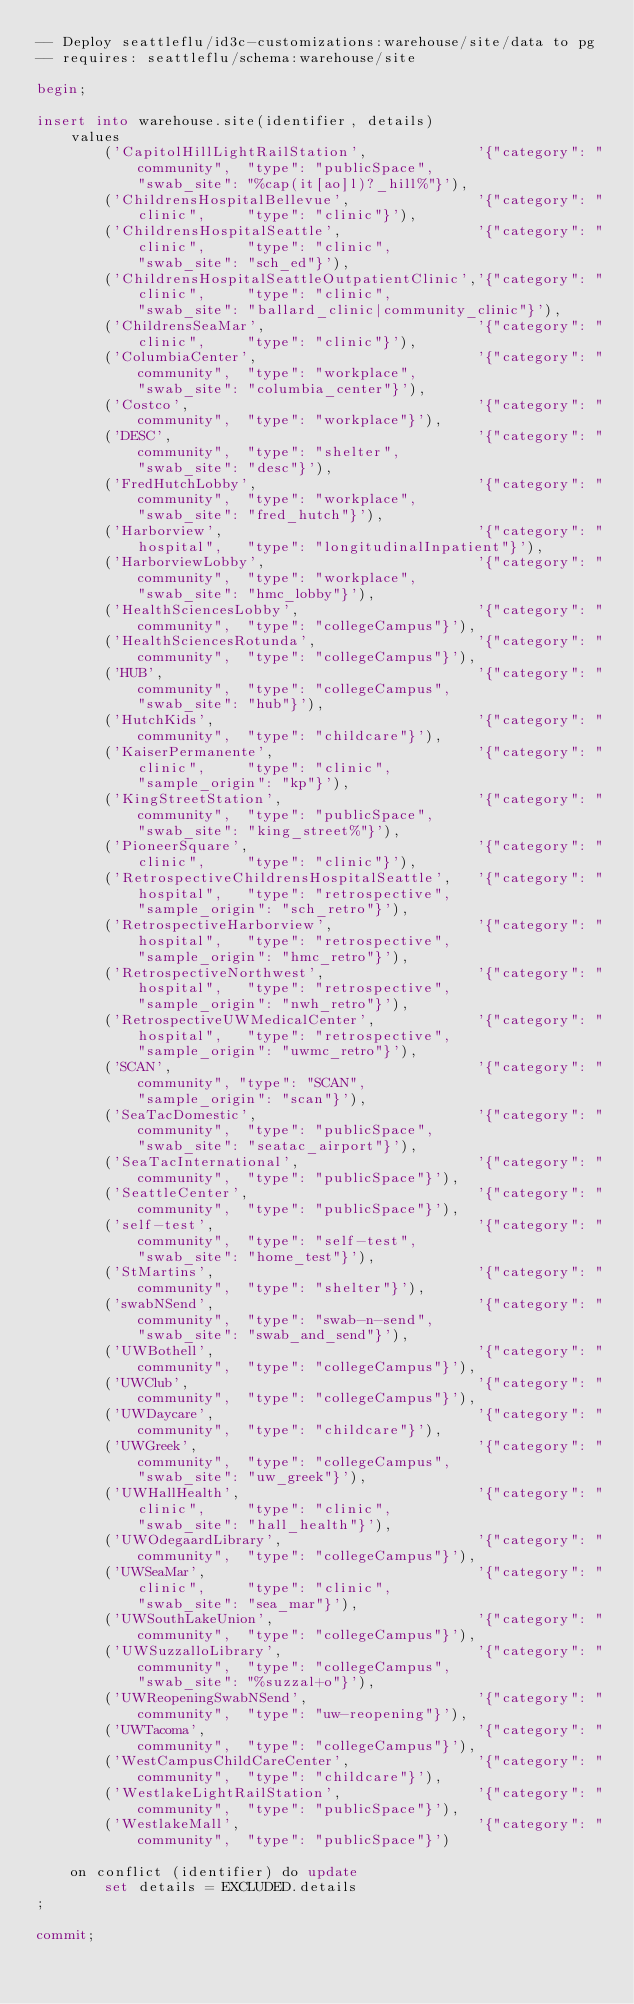Convert code to text. <code><loc_0><loc_0><loc_500><loc_500><_SQL_>-- Deploy seattleflu/id3c-customizations:warehouse/site/data to pg
-- requires: seattleflu/schema:warehouse/site

begin;

insert into warehouse.site(identifier, details)
    values
        ('CapitolHillLightRailStation',             '{"category": "community",  "type": "publicSpace",
            "swab_site": "%cap(it[ao]l)?_hill%"}'),
        ('ChildrensHospitalBellevue',               '{"category": "clinic",     "type": "clinic"}'),
        ('ChildrensHospitalSeattle',                '{"category": "clinic",     "type": "clinic",
            "swab_site": "sch_ed"}'),
        ('ChildrensHospitalSeattleOutpatientClinic','{"category": "clinic",     "type": "clinic",
            "swab_site": "ballard_clinic|community_clinic"}'),
        ('ChildrensSeaMar',                         '{"category": "clinic",     "type": "clinic"}'),
        ('ColumbiaCenter',                          '{"category": "community",  "type": "workplace",
            "swab_site": "columbia_center"}'),
        ('Costco',                                  '{"category": "community",  "type": "workplace"}'),
        ('DESC',                                    '{"category": "community",  "type": "shelter",
            "swab_site": "desc"}'),
        ('FredHutchLobby',                          '{"category": "community",  "type": "workplace",
            "swab_site": "fred_hutch"}'),
        ('Harborview',                              '{"category": "hospital",   "type": "longitudinalInpatient"}'),
        ('HarborviewLobby',                         '{"category": "community",  "type": "workplace",
            "swab_site": "hmc_lobby"}'),
        ('HealthSciencesLobby',                     '{"category": "community",  "type": "collegeCampus"}'),
        ('HealthSciencesRotunda',                   '{"category": "community",  "type": "collegeCampus"}'),
        ('HUB',                                     '{"category": "community",  "type": "collegeCampus",
            "swab_site": "hub"}'),
        ('HutchKids',                               '{"category": "community",  "type": "childcare"}'),
        ('KaiserPermanente',                        '{"category": "clinic",     "type": "clinic",
            "sample_origin": "kp"}'),
        ('KingStreetStation',                       '{"category": "community",  "type": "publicSpace",
            "swab_site": "king_street%"}'),
        ('PioneerSquare',                           '{"category": "clinic",     "type": "clinic"}'),
        ('RetrospectiveChildrensHospitalSeattle',   '{"category": "hospital",   "type": "retrospective",
            "sample_origin": "sch_retro"}'),
        ('RetrospectiveHarborview',                 '{"category": "hospital",   "type": "retrospective",
            "sample_origin": "hmc_retro"}'),
        ('RetrospectiveNorthwest',                  '{"category": "hospital",   "type": "retrospective",
            "sample_origin": "nwh_retro"}'),
        ('RetrospectiveUWMedicalCenter',            '{"category": "hospital",   "type": "retrospective",
            "sample_origin": "uwmc_retro"}'),
        ('SCAN',                                    '{"category": "community", "type": "SCAN",
            "sample_origin": "scan"}'),
        ('SeaTacDomestic',                          '{"category": "community",  "type": "publicSpace",
            "swab_site": "seatac_airport"}'),
        ('SeaTacInternational',                     '{"category": "community",  "type": "publicSpace"}'),
        ('SeattleCenter',                           '{"category": "community",  "type": "publicSpace"}'),
        ('self-test',                               '{"category": "community",  "type": "self-test",
            "swab_site": "home_test"}'),
        ('StMartins',                               '{"category": "community",  "type": "shelter"}'),
        ('swabNSend',                               '{"category": "community",  "type": "swab-n-send",
            "swab_site": "swab_and_send"}'),
        ('UWBothell',                               '{"category": "community",  "type": "collegeCampus"}'),
        ('UWClub',                                  '{"category": "community",  "type": "collegeCampus"}'),
        ('UWDaycare',                               '{"category": "community",  "type": "childcare"}'),
        ('UWGreek',                                 '{"category": "community",  "type": "collegeCampus",
            "swab_site": "uw_greek"}'),
        ('UWHallHealth',                            '{"category": "clinic",     "type": "clinic",
            "swab_site": "hall_health"}'),
        ('UWOdegaardLibrary',                       '{"category": "community",  "type": "collegeCampus"}'),
        ('UWSeaMar',                                '{"category": "clinic",     "type": "clinic",
            "swab_site": "sea_mar"}'),
        ('UWSouthLakeUnion',                        '{"category": "community",  "type": "collegeCampus"}'),
        ('UWSuzzalloLibrary',                       '{"category": "community",  "type": "collegeCampus",
            "swab_site": "%suzzal+o"}'),
        ('UWReopeningSwabNSend',                    '{"category": "community",  "type": "uw-reopening"}'),
        ('UWTacoma',                                '{"category": "community",  "type": "collegeCampus"}'),
        ('WestCampusChildCareCenter',               '{"category": "community",  "type": "childcare"}'),
        ('WestlakeLightRailStation',                '{"category": "community",  "type": "publicSpace"}'),
        ('WestlakeMall',                            '{"category": "community",  "type": "publicSpace"}')

    on conflict (identifier) do update
        set details = EXCLUDED.details
;

commit;
</code> 